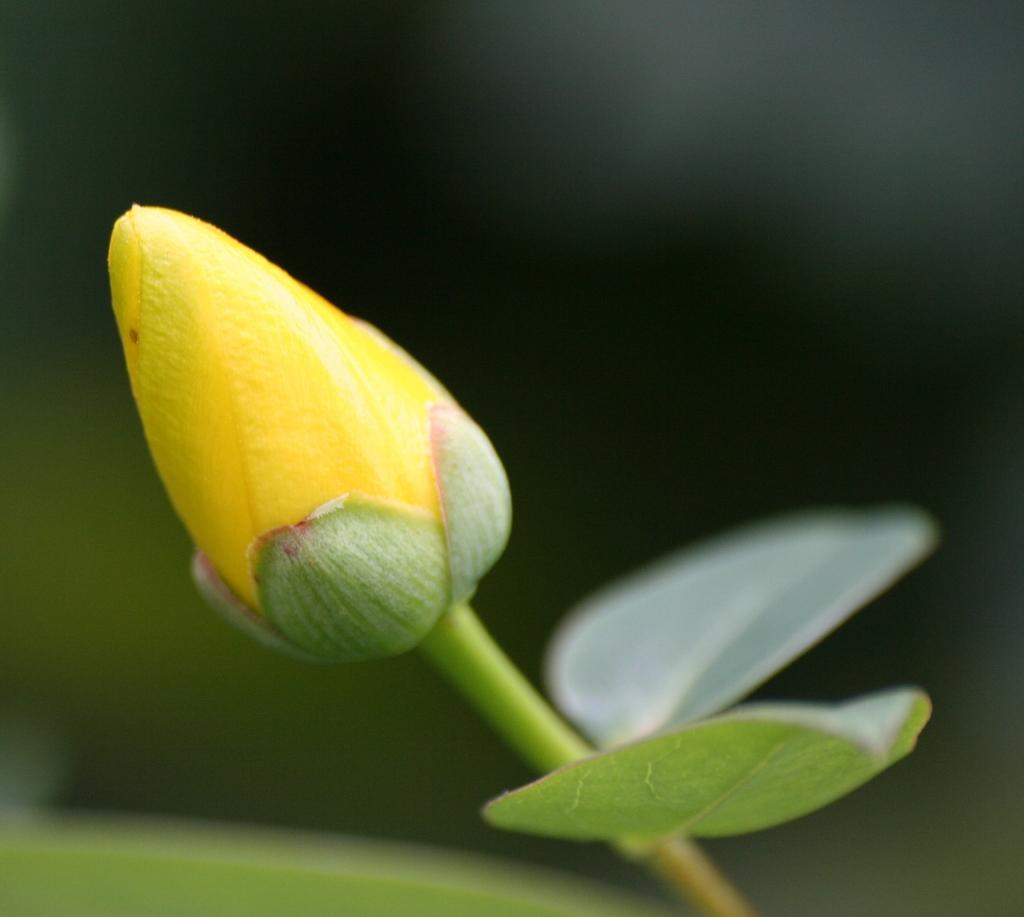What is the main subject of the image? The main subject of the image is a bud. Where are the leaves located in the image? The leaves are on the right side of the image. What color is the background of the image? The background of the image is green. Can you tell me how many rings are on the hen's neck in the image? There is no hen or rings present in the image; it features a bud and leaves. 